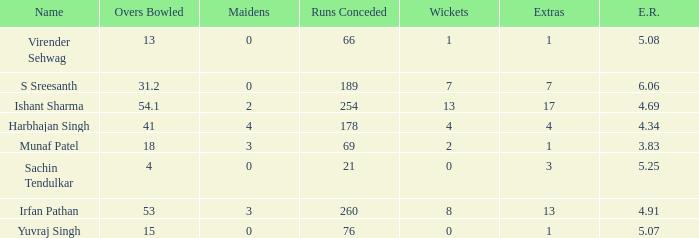Name the name for when overs bowled is 31.2 S Sreesanth. 